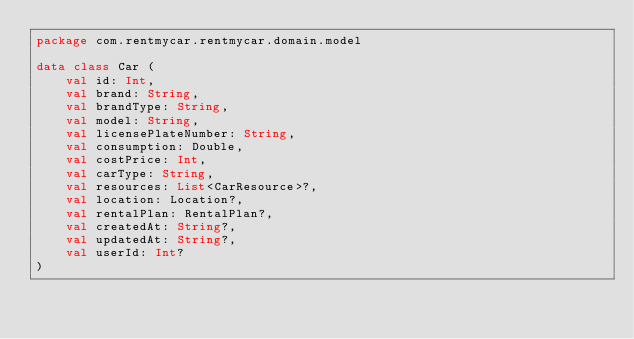<code> <loc_0><loc_0><loc_500><loc_500><_Kotlin_>package com.rentmycar.rentmycar.domain.model

data class Car (
    val id: Int,
    val brand: String,
    val brandType: String,
    val model: String,
    val licensePlateNumber: String,
    val consumption: Double,
    val costPrice: Int,
    val carType: String,
    val resources: List<CarResource>?,
    val location: Location?,
    val rentalPlan: RentalPlan?,
    val createdAt: String?,
    val updatedAt: String?,
    val userId: Int?
)</code> 